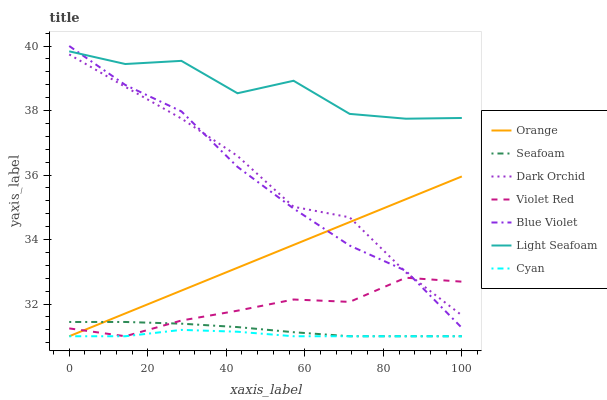Does Cyan have the minimum area under the curve?
Answer yes or no. Yes. Does Light Seafoam have the maximum area under the curve?
Answer yes or no. Yes. Does Seafoam have the minimum area under the curve?
Answer yes or no. No. Does Seafoam have the maximum area under the curve?
Answer yes or no. No. Is Orange the smoothest?
Answer yes or no. Yes. Is Light Seafoam the roughest?
Answer yes or no. Yes. Is Seafoam the smoothest?
Answer yes or no. No. Is Seafoam the roughest?
Answer yes or no. No. Does Violet Red have the lowest value?
Answer yes or no. Yes. Does Dark Orchid have the lowest value?
Answer yes or no. No. Does Blue Violet have the highest value?
Answer yes or no. Yes. Does Seafoam have the highest value?
Answer yes or no. No. Is Cyan less than Light Seafoam?
Answer yes or no. Yes. Is Light Seafoam greater than Violet Red?
Answer yes or no. Yes. Does Dark Orchid intersect Orange?
Answer yes or no. Yes. Is Dark Orchid less than Orange?
Answer yes or no. No. Is Dark Orchid greater than Orange?
Answer yes or no. No. Does Cyan intersect Light Seafoam?
Answer yes or no. No. 